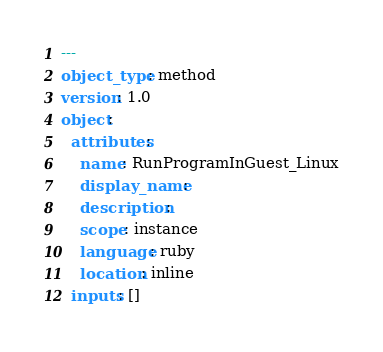Convert code to text. <code><loc_0><loc_0><loc_500><loc_500><_YAML_>---
object_type: method
version: 1.0
object:
  attributes:
    name: RunProgramInGuest_Linux
    display_name: 
    description: 
    scope: instance
    language: ruby
    location: inline
  inputs: []
</code> 